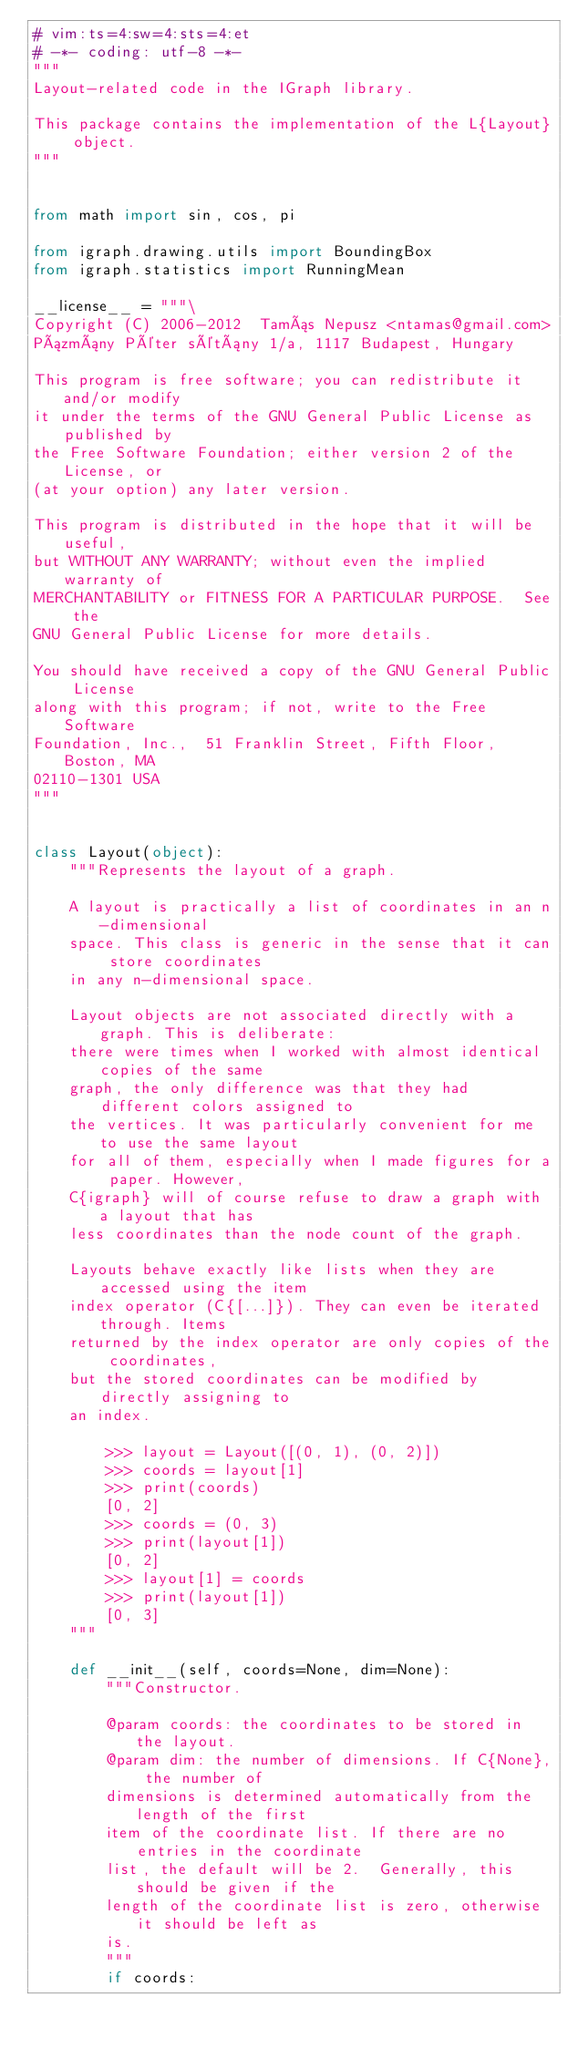<code> <loc_0><loc_0><loc_500><loc_500><_Python_># vim:ts=4:sw=4:sts=4:et
# -*- coding: utf-8 -*-
"""
Layout-related code in the IGraph library.

This package contains the implementation of the L{Layout} object.
"""


from math import sin, cos, pi

from igraph.drawing.utils import BoundingBox
from igraph.statistics import RunningMean

__license__ = """\
Copyright (C) 2006-2012  Tamás Nepusz <ntamas@gmail.com>
Pázmány Péter sétány 1/a, 1117 Budapest, Hungary

This program is free software; you can redistribute it and/or modify
it under the terms of the GNU General Public License as published by
the Free Software Foundation; either version 2 of the License, or
(at your option) any later version.

This program is distributed in the hope that it will be useful,
but WITHOUT ANY WARRANTY; without even the implied warranty of
MERCHANTABILITY or FITNESS FOR A PARTICULAR PURPOSE.  See the
GNU General Public License for more details.

You should have received a copy of the GNU General Public License
along with this program; if not, write to the Free Software
Foundation, Inc.,  51 Franklin Street, Fifth Floor, Boston, MA 
02110-1301 USA
"""


class Layout(object):
    """Represents the layout of a graph.

    A layout is practically a list of coordinates in an n-dimensional
    space. This class is generic in the sense that it can store coordinates
    in any n-dimensional space.

    Layout objects are not associated directly with a graph. This is deliberate:
    there were times when I worked with almost identical copies of the same
    graph, the only difference was that they had different colors assigned to
    the vertices. It was particularly convenient for me to use the same layout
    for all of them, especially when I made figures for a paper. However,
    C{igraph} will of course refuse to draw a graph with a layout that has
    less coordinates than the node count of the graph.

    Layouts behave exactly like lists when they are accessed using the item
    index operator (C{[...]}). They can even be iterated through. Items
    returned by the index operator are only copies of the coordinates,
    but the stored coordinates can be modified by directly assigning to
    an index.

        >>> layout = Layout([(0, 1), (0, 2)])
        >>> coords = layout[1]
        >>> print(coords)
        [0, 2]
        >>> coords = (0, 3)
        >>> print(layout[1])
        [0, 2]
        >>> layout[1] = coords
        >>> print(layout[1])
        [0, 3]
    """

    def __init__(self, coords=None, dim=None):
        """Constructor.

        @param coords: the coordinates to be stored in the layout.
        @param dim: the number of dimensions. If C{None}, the number of
        dimensions is determined automatically from the length of the first
        item of the coordinate list. If there are no entries in the coordinate
        list, the default will be 2.  Generally, this should be given if the
        length of the coordinate list is zero, otherwise it should be left as
        is.
        """
        if coords:</code> 